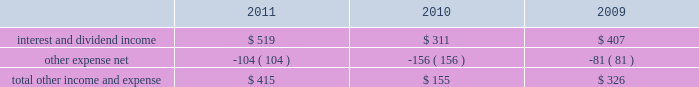R&d expense increased 36% ( 36 % ) during 2011 compared to 2010 , it declined slightly as a percentage of net sales , due to the 66% ( 66 % ) year-over-year growth in the company 2019s net sales during 2011 .
R&d expense increased 34% ( 34 % ) or $ 449 million to $ 1.8 billion in 2010 compared to 2009 .
This increase was due primarily to an increase in headcount and related expenses in the current year to support expanded r&d activities .
Also contributing to this increase in r&d expense in 2010 was the capitalization in 2009 of software development costs of $ 71 million related to mac os x snow leopard .
Although total r&d expense increased 34% ( 34 % ) during 2010 , it declined as a percentage of net sales given the 52% ( 52 % ) year-over-year increase in net sales in the company continues to believe that focused investments in r&d are critical to its future growth and competitive position in the marketplace and are directly related to timely development of new and enhanced products that are central to the company 2019s core business strategy .
As such , the company expects to make further investments in r&d to remain competitive .
Selling , general and administrative expense ( 201csg&a 201d ) sg&a expense increased $ 2.1 billion or 38% ( 38 % ) to $ 7.6 billion during 2011 compared to 2010 .
This increase was due primarily to the company 2019s continued expansion of its retail segment , increased headcount and related costs , higher spending on professional services and marketing and advertising programs , and increased variable costs associated with the overall growth of the company 2019s net sales .
Sg&a expense increased $ 1.4 billion or 33% ( 33 % ) to $ 5.5 billion in 2010 compared to 2009 .
This increase was due primarily to the company 2019s continued expansion of its retail segment , higher spending on marketing and advertising programs , increased share-based compensation expenses and variable costs associated with the overall growth of the company 2019s net sales .
Other income and expense other income and expense for the three years ended september 24 , 2011 , are as follows ( in millions ) : .
Total other income and expense increased $ 260 million or 168% ( 168 % ) to $ 415 million during 2011 compared to $ 155 million and $ 326 million in 2010 and 2009 , respectively .
The year-over-year increase in other income and expense during 2011 was due primarily to higher interest income and net realized gains on sales of marketable securities .
The overall decrease in other income and expense in 2010 compared to 2009 was attributable to the significant declines in interest rates on a year-over-year basis , partially offset by the company 2019s higher cash , cash equivalents and marketable securities balances .
Additionally the company incurred higher premium expenses on its foreign exchange option contracts , which further reduced the total other income and expense .
The weighted average interest rate earned by the company on its cash , cash equivalents and marketable securities was 0.77% ( 0.77 % ) , 0.75% ( 0.75 % ) and 1.43% ( 1.43 % ) during 2011 , 2010 and 2009 , respectively .
During 2011 , 2010 and 2009 , the company had no debt outstanding and accordingly did not incur any related interest expense .
Provision for income taxes the company 2019s effective tax rates were approximately 24.2% ( 24.2 % ) , 24.4% ( 24.4 % ) and 31.8% ( 31.8 % ) for 2011 , 2010 and 2009 , respectively .
The company 2019s effective rates for these periods differ from the statutory federal income tax rate of .
Interest and dividend income was what percent of total other income in 2011? 
Computations: (519 / 415)
Answer: 1.2506. 